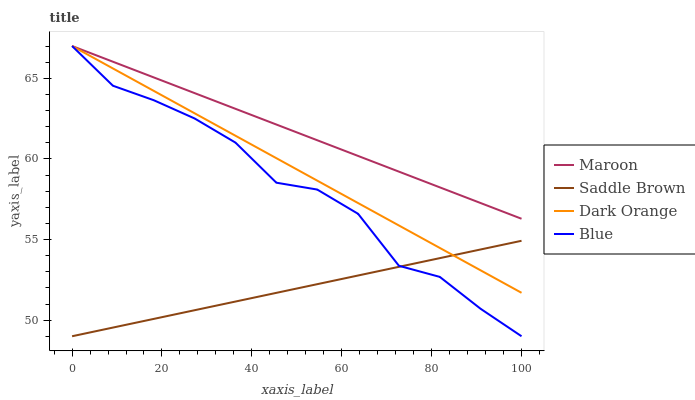Does Saddle Brown have the minimum area under the curve?
Answer yes or no. Yes. Does Maroon have the maximum area under the curve?
Answer yes or no. Yes. Does Dark Orange have the minimum area under the curve?
Answer yes or no. No. Does Dark Orange have the maximum area under the curve?
Answer yes or no. No. Is Maroon the smoothest?
Answer yes or no. Yes. Is Blue the roughest?
Answer yes or no. Yes. Is Dark Orange the smoothest?
Answer yes or no. No. Is Dark Orange the roughest?
Answer yes or no. No. Does Blue have the lowest value?
Answer yes or no. Yes. Does Dark Orange have the lowest value?
Answer yes or no. No. Does Maroon have the highest value?
Answer yes or no. Yes. Does Saddle Brown have the highest value?
Answer yes or no. No. Is Saddle Brown less than Maroon?
Answer yes or no. Yes. Is Maroon greater than Saddle Brown?
Answer yes or no. Yes. Does Blue intersect Dark Orange?
Answer yes or no. Yes. Is Blue less than Dark Orange?
Answer yes or no. No. Is Blue greater than Dark Orange?
Answer yes or no. No. Does Saddle Brown intersect Maroon?
Answer yes or no. No. 